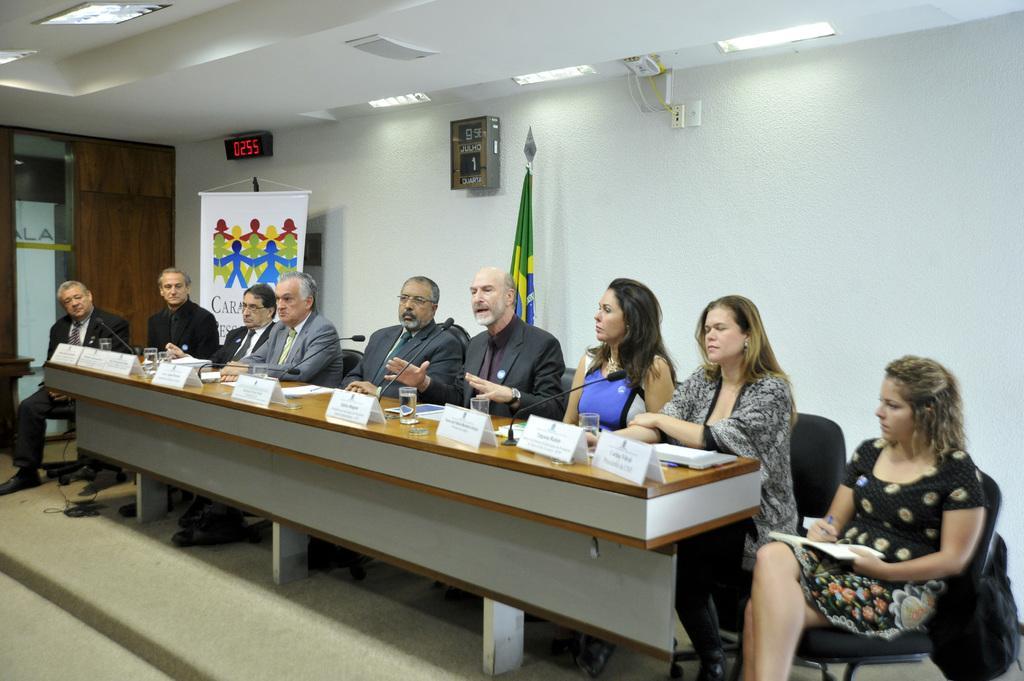Could you give a brief overview of what you see in this image? It looks like a conference room. Few peoples are sat on the chair. Here we can see desk, name boards, microphones, glasses with water. On the right side, we can see bag. And background, we can see flag, white color wall. White roof. Click here. Banner. On the left side, we can see wooden cupboard, glass. 